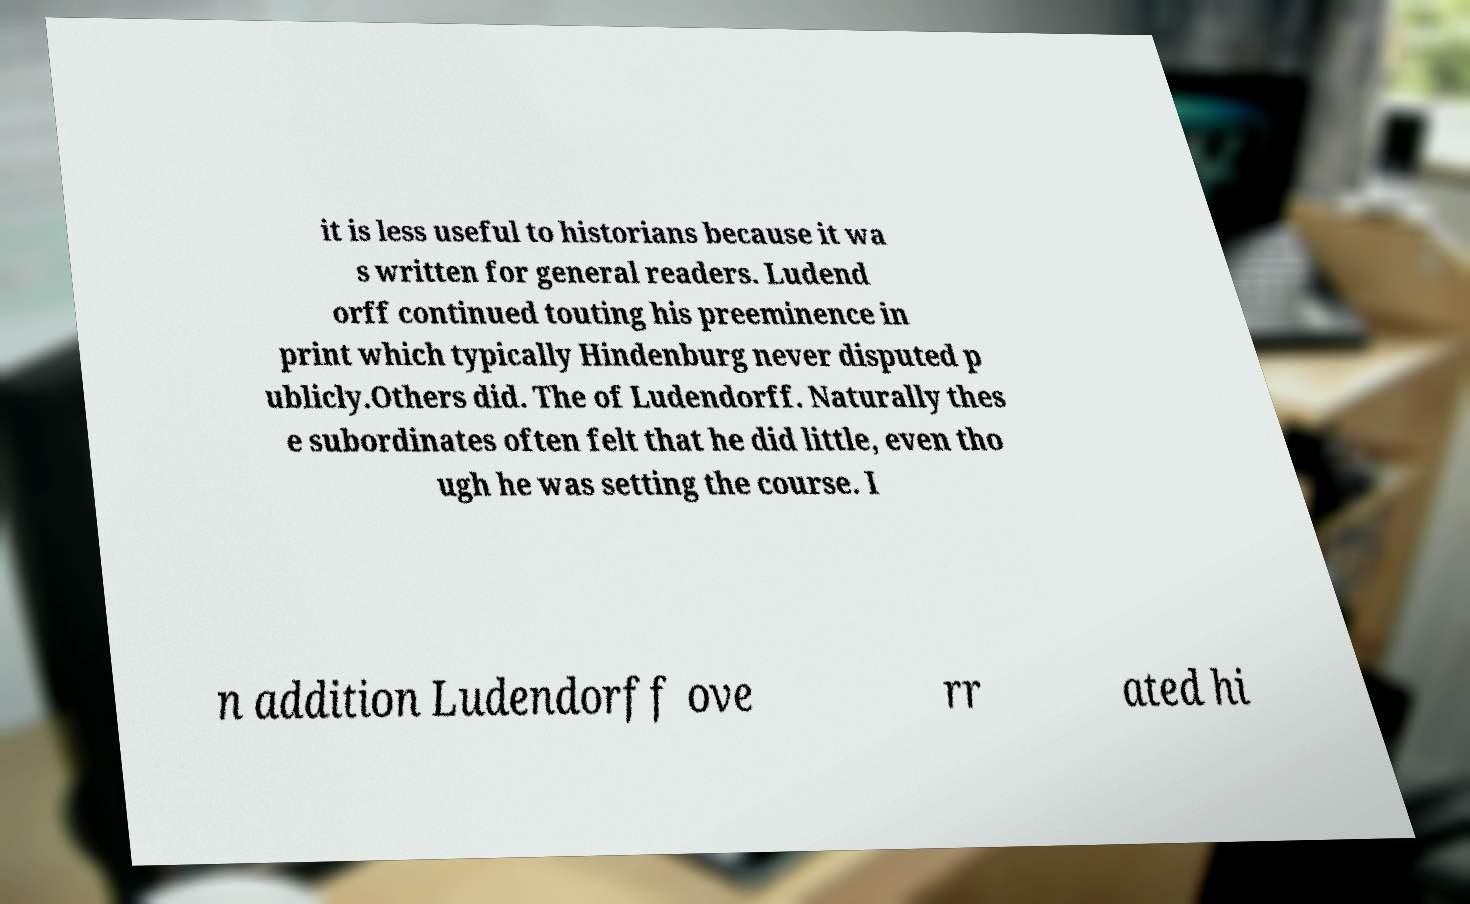Can you read and provide the text displayed in the image?This photo seems to have some interesting text. Can you extract and type it out for me? it is less useful to historians because it wa s written for general readers. Ludend orff continued touting his preeminence in print which typically Hindenburg never disputed p ublicly.Others did. The of Ludendorff. Naturally thes e subordinates often felt that he did little, even tho ugh he was setting the course. I n addition Ludendorff ove rr ated hi 